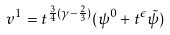<formula> <loc_0><loc_0><loc_500><loc_500>v ^ { 1 } = t ^ { \frac { 3 } { 4 } ( \gamma - \frac { 2 } { 3 } ) } ( \psi ^ { 0 } + t ^ { \epsilon } \tilde { \psi } )</formula> 